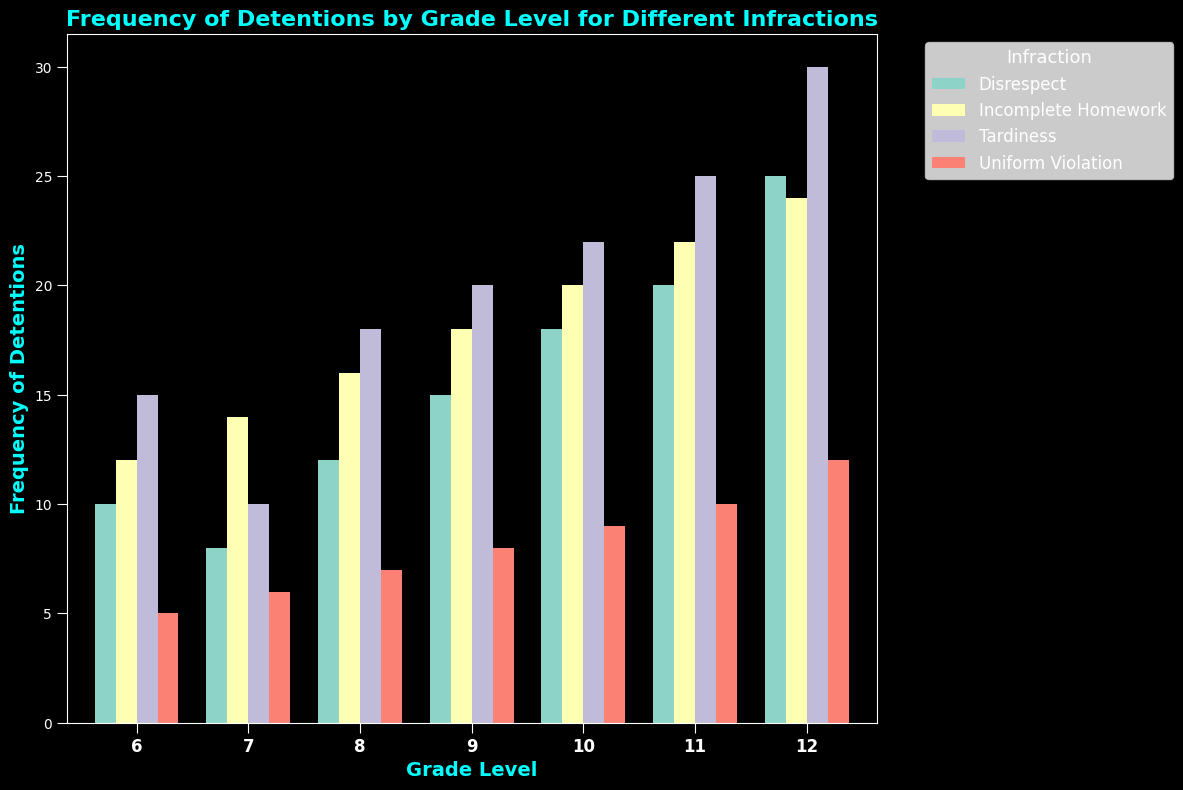What grade level has the highest frequency of detentions for Tardiness? Look at the bars representing Tardiness and compare their heights; the tallest bar is for grade 12.
Answer: Grade 12 Which infraction has the second highest frequency of detentions in grade 11? For grade 11, compare the bars representing different infractions. Tardiness has the highest, and Disrespect is second.
Answer: Disrespect What is the total frequency of detentions for Incomplete Homework in grades 9 and 10 combined? Add the frequencies for grades 9 and 10: 18 (grade 9) + 20 (grade 10).
Answer: 38 Is the frequency of detentions for Uniform Violation greater in grade 6 or grade 7? Compare the heights of the bars for Uniform Violation in grades 6 and 7. Grade 7 has a higher value (6 vs. 5).
Answer: Grade 7 What is the average frequency of detentions for Tardiness across all grades? Sum the frequencies for Tardiness across all grades and then divide by the number of grades (15+10+18+20+22+25+30) / 7.
Answer: 20 Which infraction has the lowest frequency of detentions in grade 8? For grade 8, compare the bars representing different infractions; Uniform Violation has the lowest.
Answer: Uniform Violation Compare the frequencies of detentions for Disrespect in grades 10 and 12. Note the heights of the bars for Disrespect in grades 10 and 12. Grade 12 has a higher frequency (25 vs. 18).
Answer: Grade 12 has higher What is the sum of frequencies for Uniform Violations in grades 10, 11, and 12? Add the frequencies for these grades: 9 (grade 10) + 10 (grade 11) + 12 (grade 12).
Answer: 31 Is the frequency of detentions for Tardiness in grade 12 more than the total frequency of detentions for Disrespect in grades 6 and 7 combined? Compare the frequency of Tardiness in grade 12 (30) with the sum of Disrespect in grades 6 and 7 (10+8).
Answer: Yes Which grade has the highest total frequency of detentions for all infractions combined? Sum the frequencies of all infractions for each grade, and compare these sums. Grade 12 has the highest total.
Answer: Grade 12 